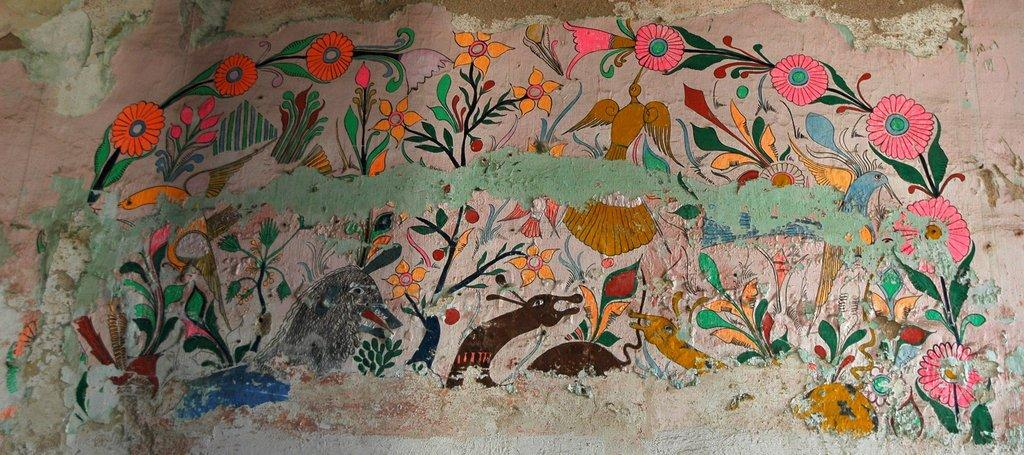What is present on the wall in the image? There is a painting on the wall in the image. What type of hand can be seen holding the painting in the image? There is no hand visible in the image holding the painting. The painting is simply on the wall. 